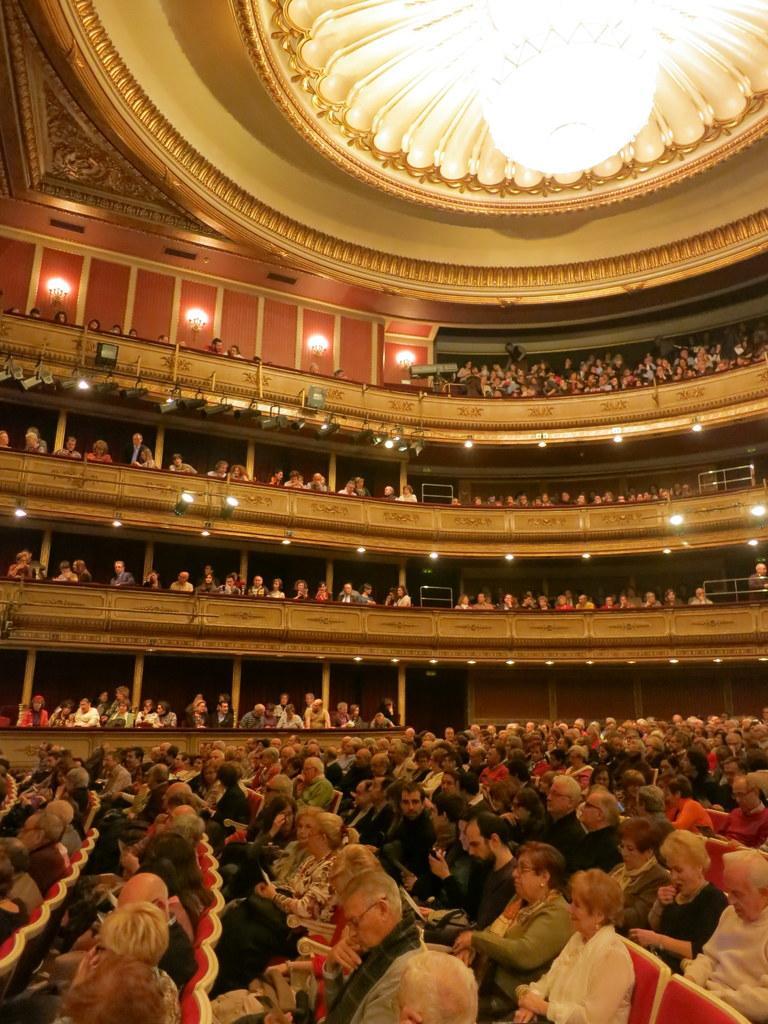Could you give a brief overview of what you see in this image? In this picture we can see a group of people sitting on chairs and some people are standing and this is an inside view of a building. 